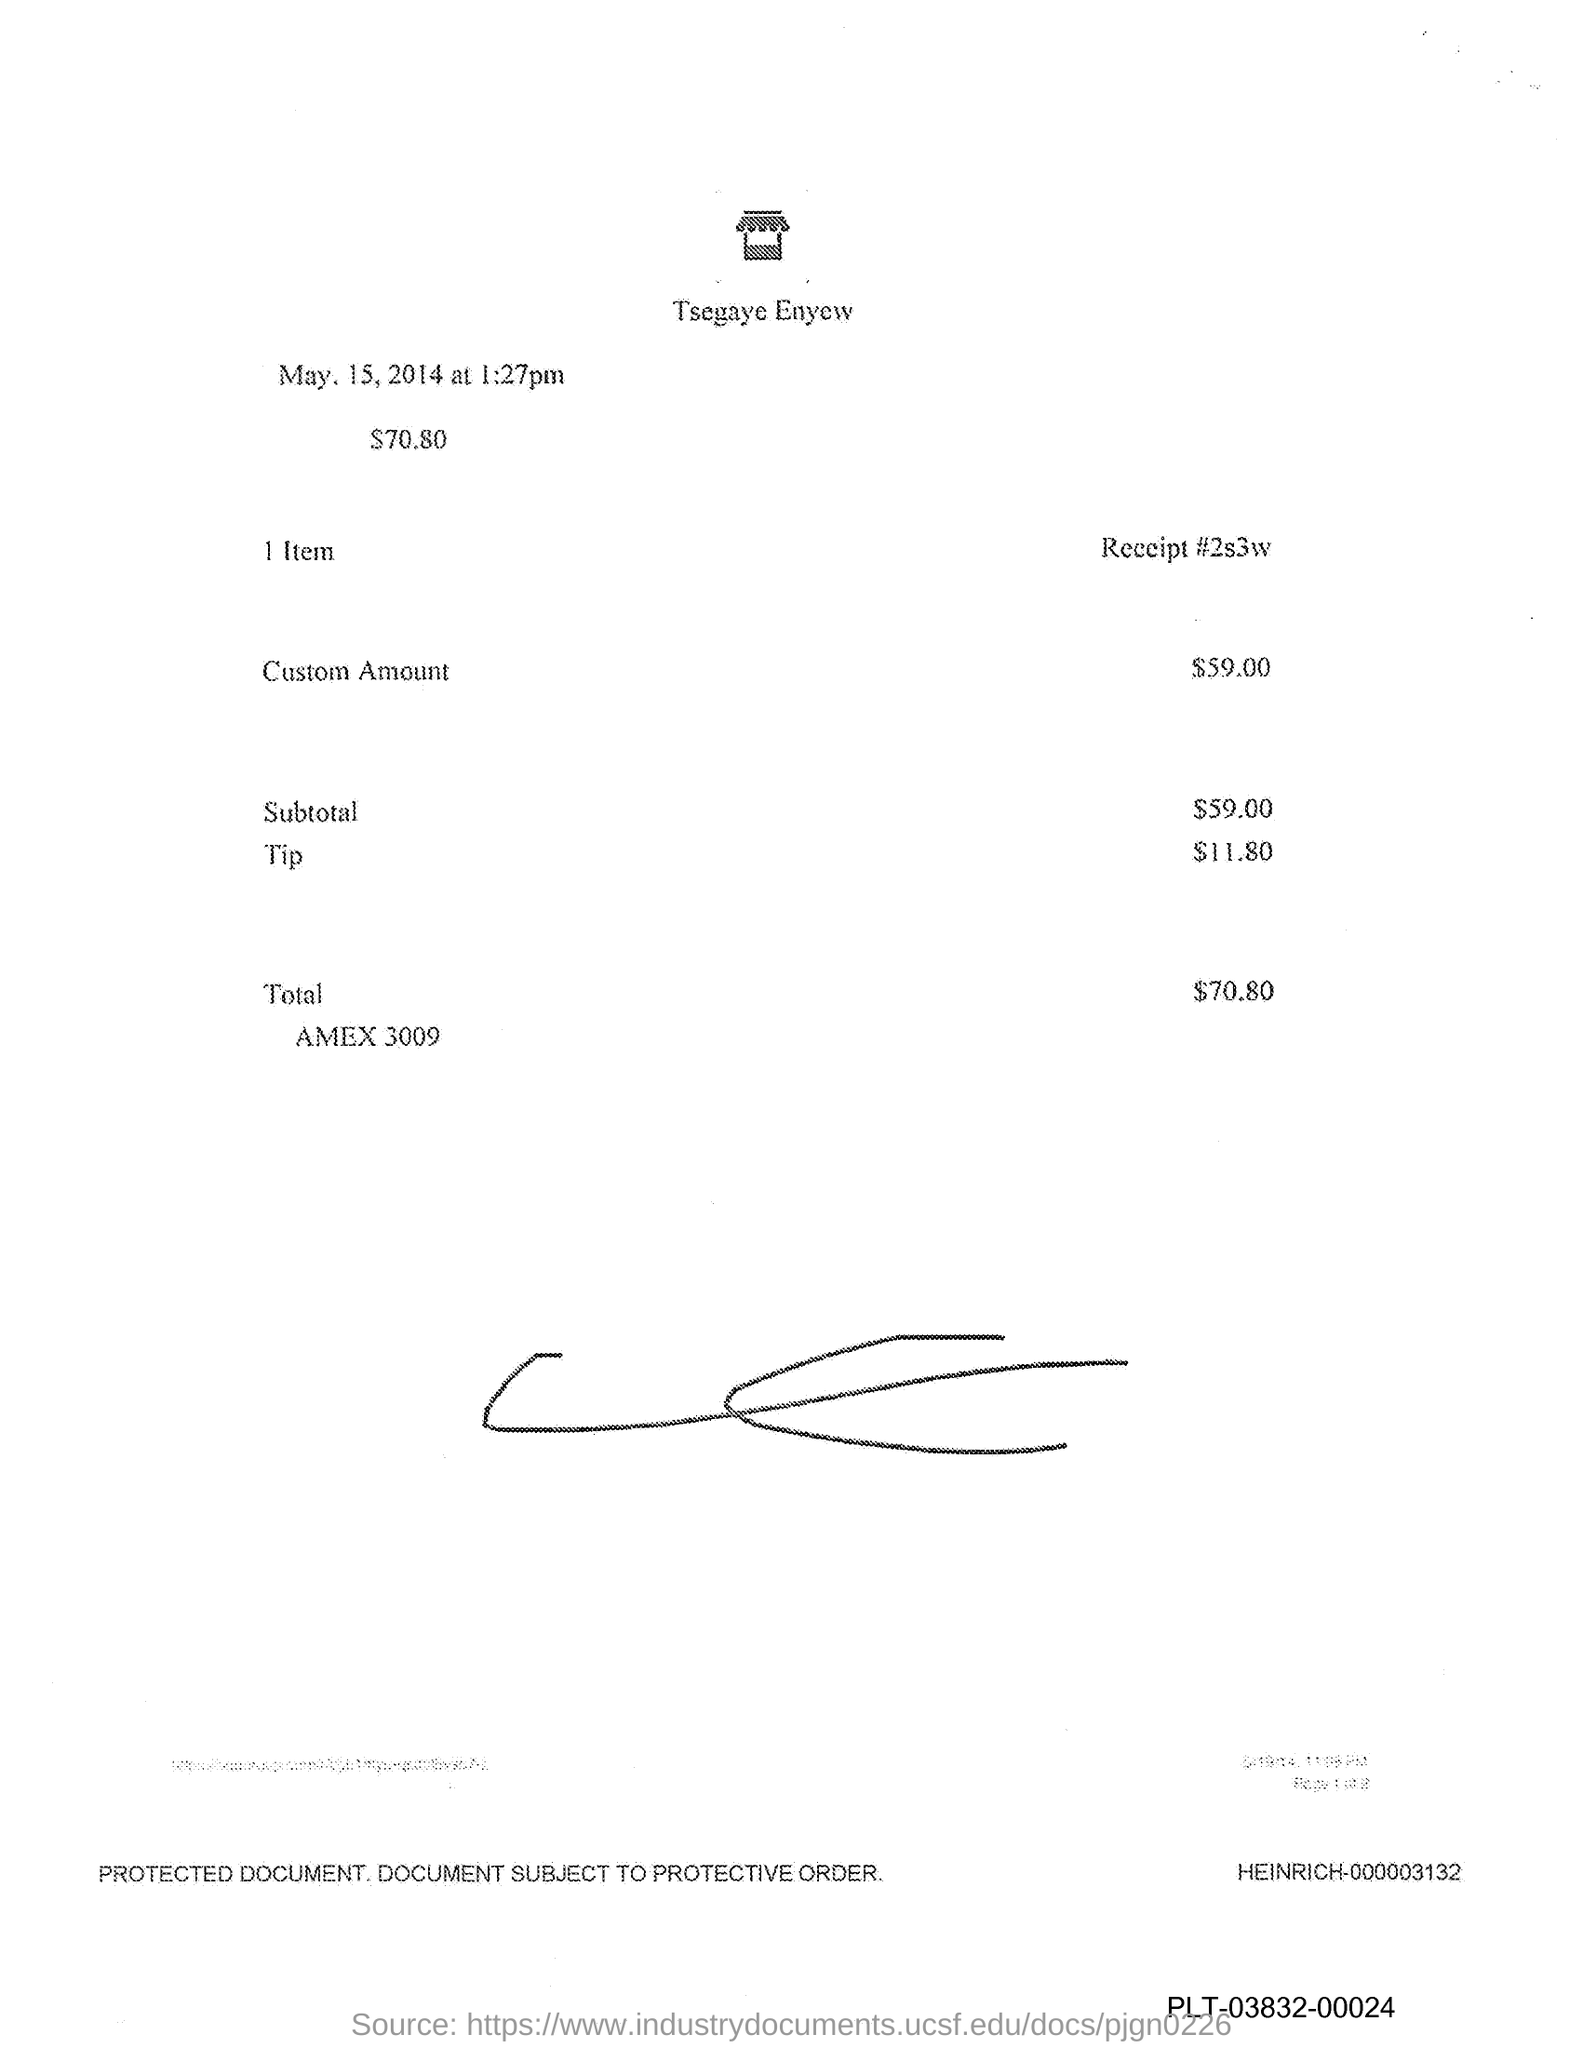Highlight a few significant elements in this photo. The tip mentioned in the document is $11.80. The custom amount stated in the document is $59.00. 